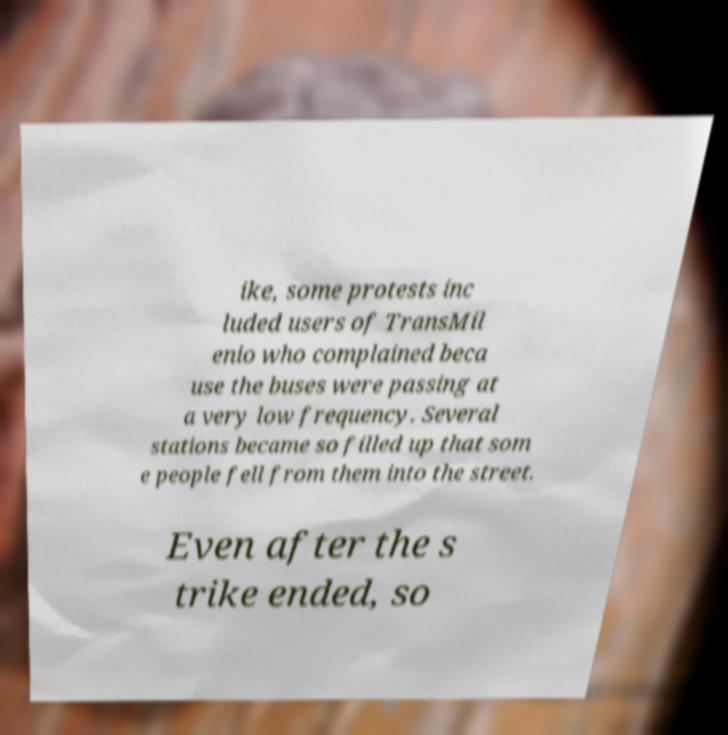Please read and relay the text visible in this image. What does it say? ike, some protests inc luded users of TransMil enio who complained beca use the buses were passing at a very low frequency. Several stations became so filled up that som e people fell from them into the street. Even after the s trike ended, so 